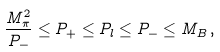Convert formula to latex. <formula><loc_0><loc_0><loc_500><loc_500>\frac { M _ { \pi } ^ { 2 } } { P _ { - } } \leq P _ { + } \leq P _ { l } \leq P _ { - } \leq M _ { B } \, ,</formula> 